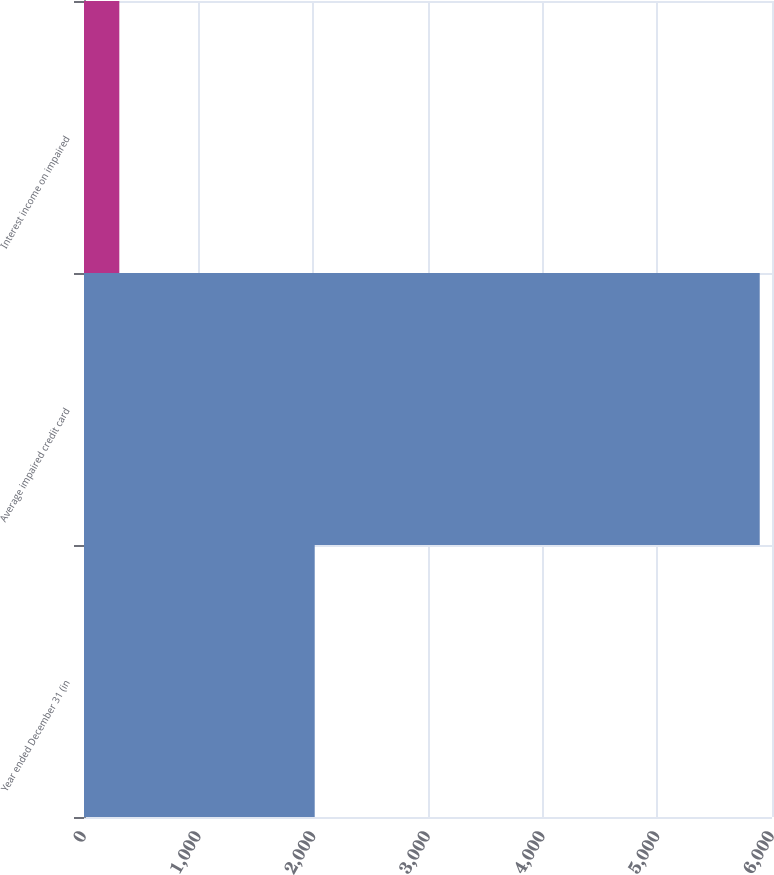Convert chart to OTSL. <chart><loc_0><loc_0><loc_500><loc_500><bar_chart><fcel>Year ended December 31 (in<fcel>Average impaired credit card<fcel>Interest income on impaired<nl><fcel>2012<fcel>5893<fcel>308<nl></chart> 